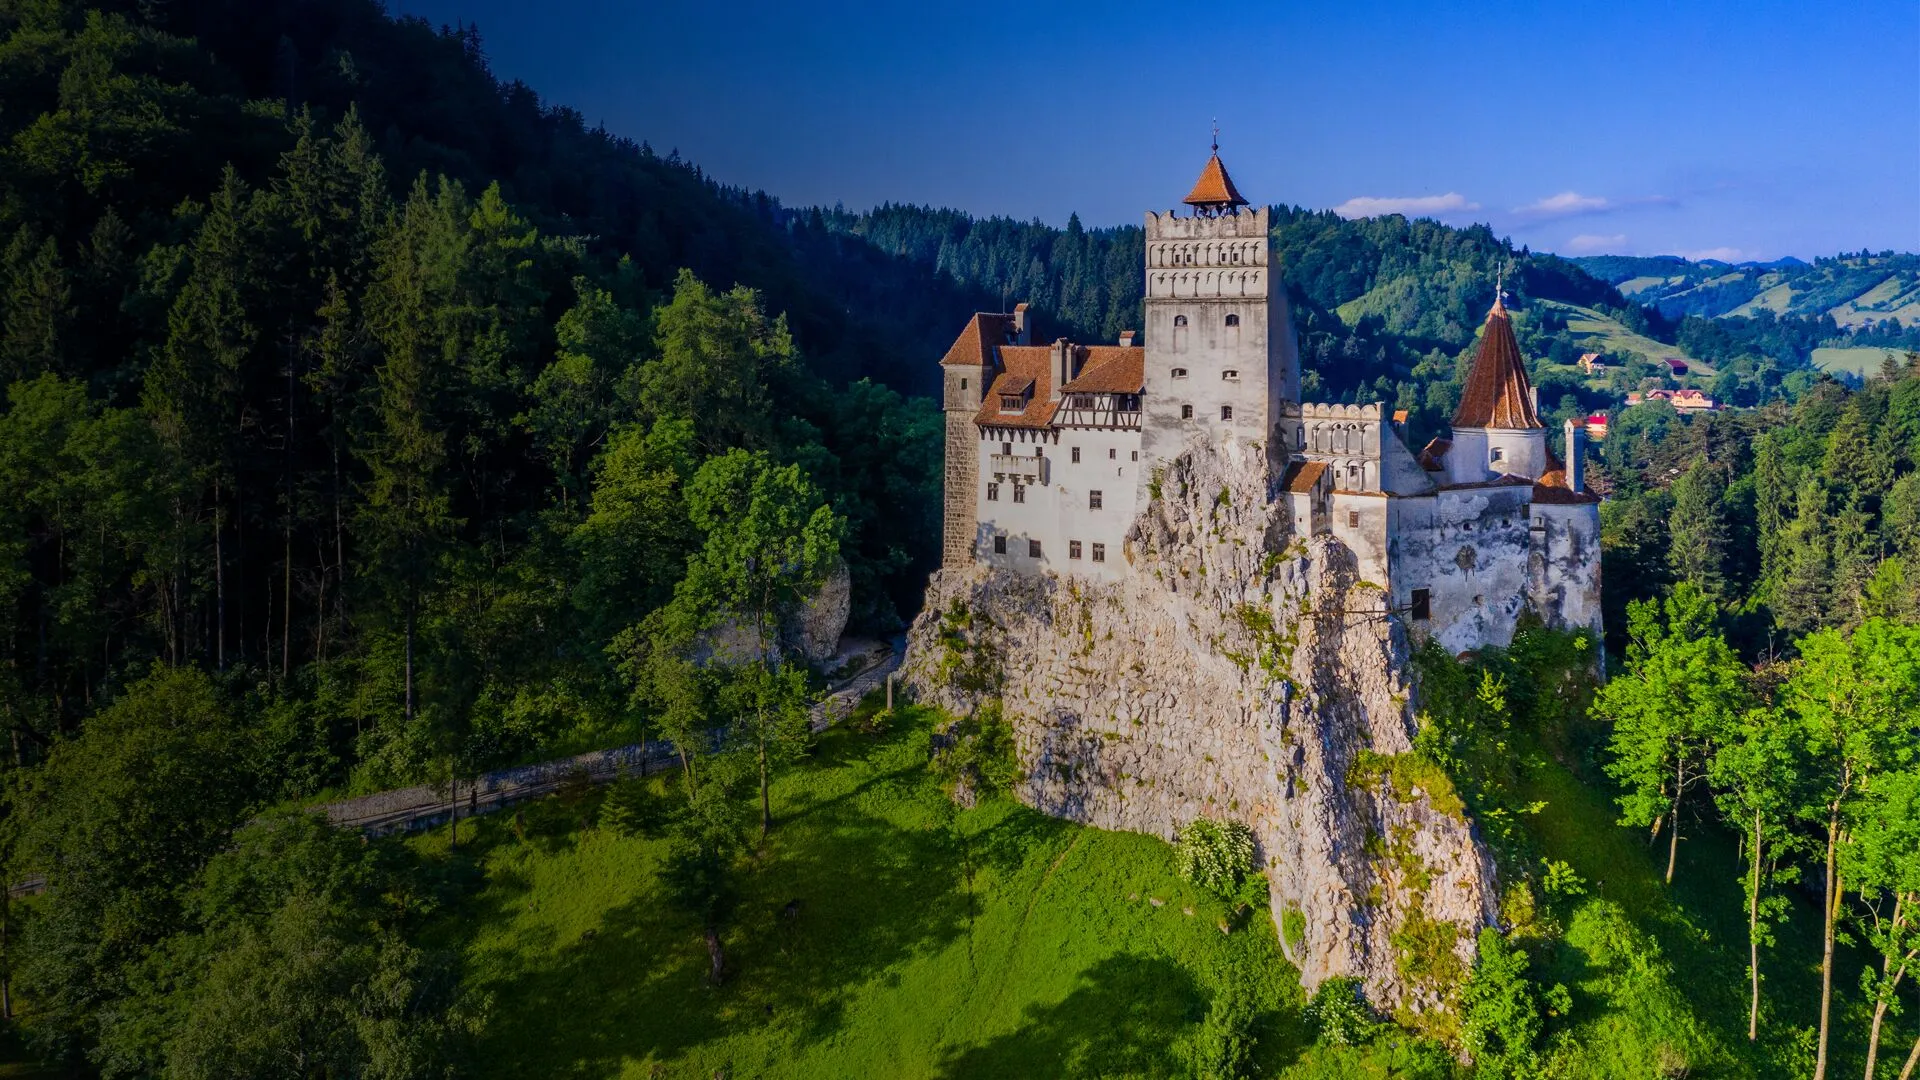Can you describe a day in the life of someone living in this castle during medieval times? Imagine waking up at dawn to the sound of the castle's bell ringing, signaling the start of a new day. As a resident of Bran Castle in medieval times, you begin with a hearty breakfast of bread, cheese, and freshly churned butter, perhaps with some spiced wine or ale. Your day might involve a variety of tasks: if you are a guard, you would patrol the castle walls, keeping an eye out for any potential threats. If you are a servant, you might be tasked with cleaning the grand halls, preparing meals in the vast kitchens, or tending to the gardens. Nobles and residents often engage in strategic meetings or social gatherings in the great hall, where the fire crackles warmly in the hearth. As the evening approaches, the castle is bathed in the golden light of sunset, casting long shadows across the courtyard. Dinner is a communal affair with an assortment of meats, stews, and freshly baked bread, followed by entertainment such as music or storytelling. As night falls, the castle grows quiet, save for the occasional howl of the wind or the hoot of an owl, enveloping its inhabitants in the tranquility of the medieval stronghold. 